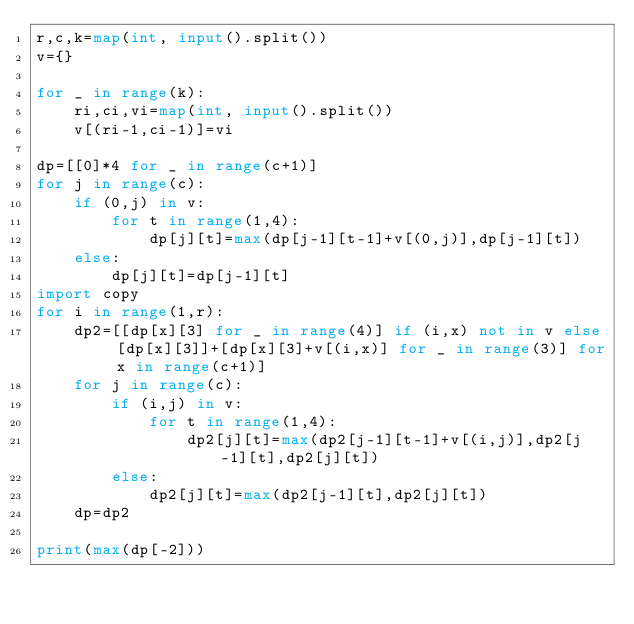<code> <loc_0><loc_0><loc_500><loc_500><_Python_>r,c,k=map(int, input().split())
v={}

for _ in range(k):
    ri,ci,vi=map(int, input().split())
    v[(ri-1,ci-1)]=vi
    
dp=[[0]*4 for _ in range(c+1)]
for j in range(c):
    if (0,j) in v:
        for t in range(1,4):
            dp[j][t]=max(dp[j-1][t-1]+v[(0,j)],dp[j-1][t])
    else:
        dp[j][t]=dp[j-1][t]
import copy
for i in range(1,r):
    dp2=[[dp[x][3] for _ in range(4)] if (i,x) not in v else [dp[x][3]]+[dp[x][3]+v[(i,x)] for _ in range(3)] for x in range(c+1)]
    for j in range(c):
        if (i,j) in v:
            for t in range(1,4):
                dp2[j][t]=max(dp2[j-1][t-1]+v[(i,j)],dp2[j-1][t],dp2[j][t])
        else:
            dp2[j][t]=max(dp2[j-1][t],dp2[j][t])
    dp=dp2

print(max(dp[-2]))


</code> 